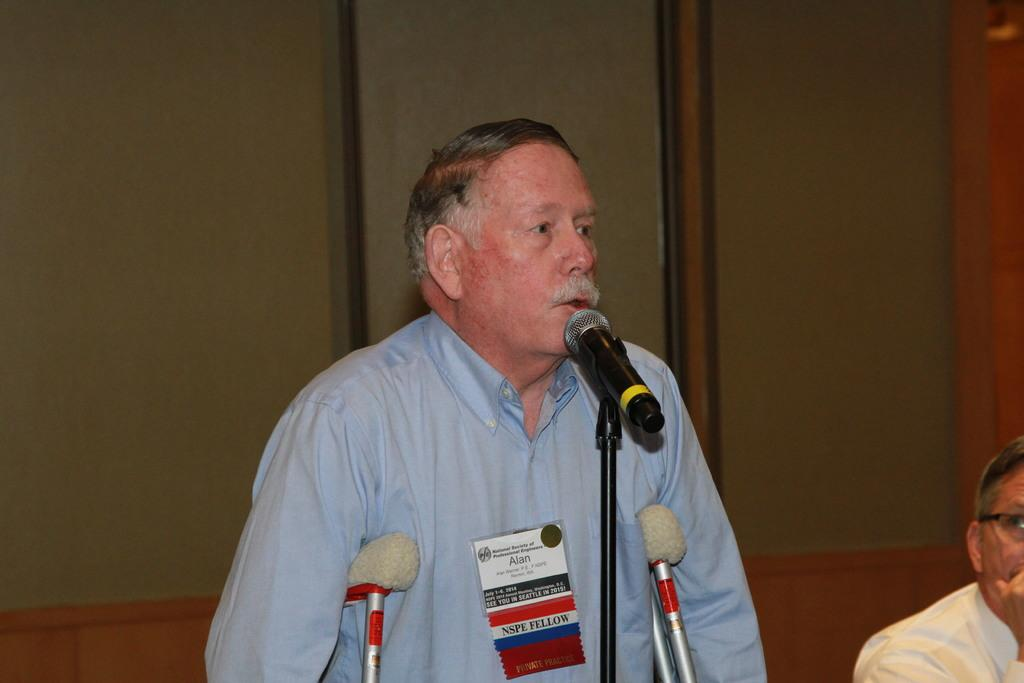What is the person in the image doing? The person in the image is speaking in front of a mic. Who is present with the speaker in the image? There is another person sitting beside the speaker in the image. What can be seen behind the two people? There is a wooden wall behind the two people. How many bikes are parked in front of the wooden wall in the image? There are no bikes present in the image; it only features two people and a wooden wall. 